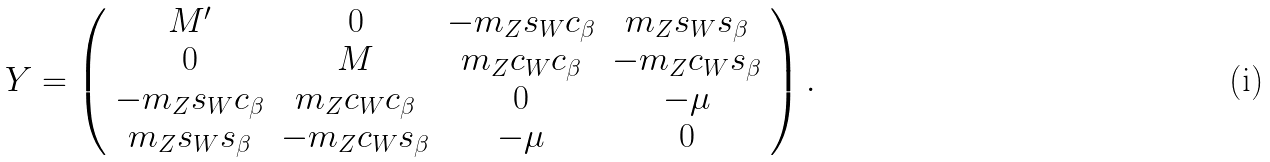<formula> <loc_0><loc_0><loc_500><loc_500>Y = \left ( \begin{array} { c c c c } M ^ { \prime } & 0 & - m _ { Z } s _ { W } c _ { \beta } & m _ { Z } s _ { W } s _ { \beta } \\ 0 & M & m _ { Z } c _ { W } c _ { \beta } & - m _ { Z } c _ { W } s _ { \beta } \\ - m _ { Z } s _ { W } c _ { \beta } & m _ { Z } c _ { W } c _ { \beta } & 0 & - \mu \\ m _ { Z } s _ { W } s _ { \beta } & - m _ { Z } c _ { W } s _ { \beta } & - \mu & 0 \\ \end{array} \right ) .</formula> 